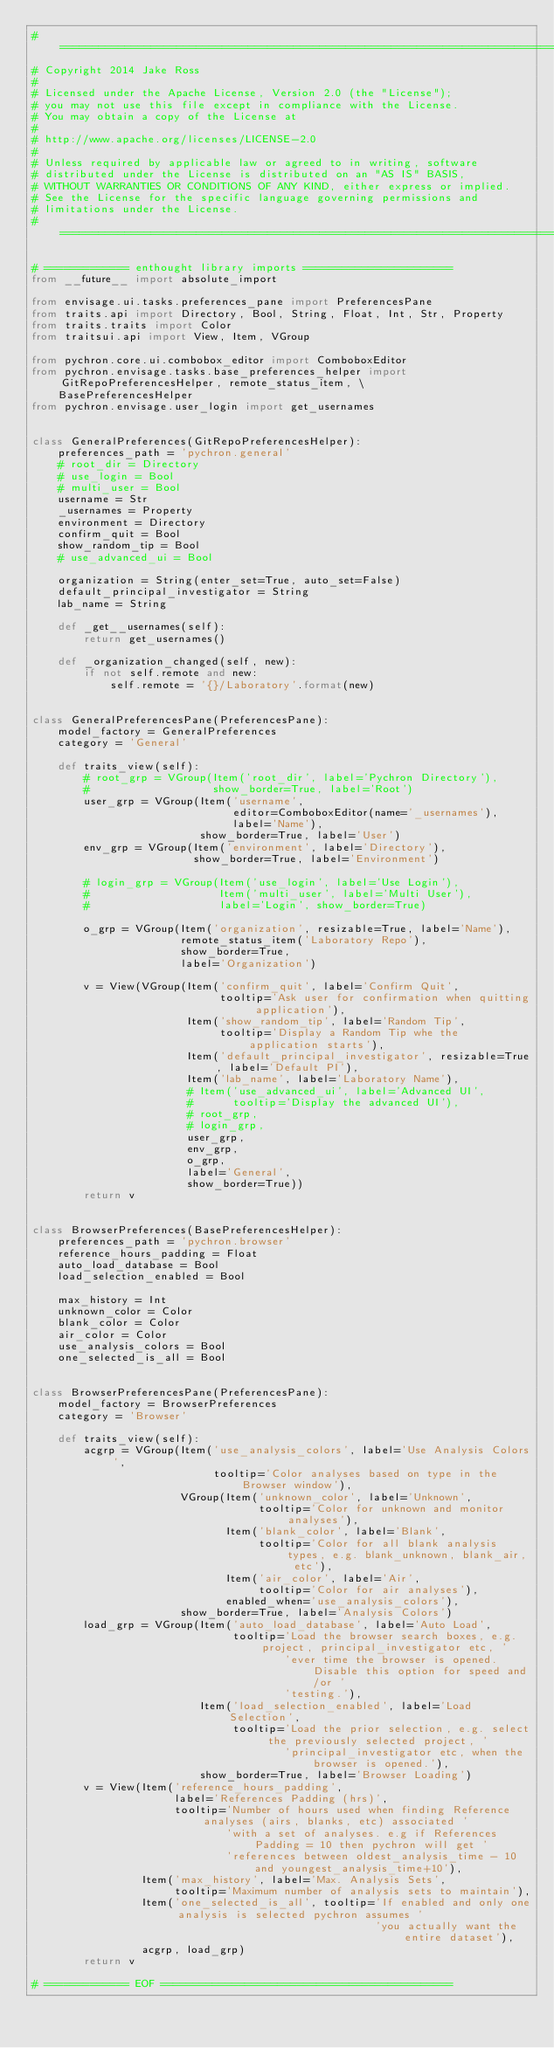<code> <loc_0><loc_0><loc_500><loc_500><_Python_># ===============================================================================
# Copyright 2014 Jake Ross
#
# Licensed under the Apache License, Version 2.0 (the "License");
# you may not use this file except in compliance with the License.
# You may obtain a copy of the License at
#
# http://www.apache.org/licenses/LICENSE-2.0
#
# Unless required by applicable law or agreed to in writing, software
# distributed under the License is distributed on an "AS IS" BASIS,
# WITHOUT WARRANTIES OR CONDITIONS OF ANY KIND, either express or implied.
# See the License for the specific language governing permissions and
# limitations under the License.
# ===============================================================================

# ============= enthought library imports =======================
from __future__ import absolute_import

from envisage.ui.tasks.preferences_pane import PreferencesPane
from traits.api import Directory, Bool, String, Float, Int, Str, Property
from traits.traits import Color
from traitsui.api import View, Item, VGroup

from pychron.core.ui.combobox_editor import ComboboxEditor
from pychron.envisage.tasks.base_preferences_helper import GitRepoPreferencesHelper, remote_status_item, \
    BasePreferencesHelper
from pychron.envisage.user_login import get_usernames


class GeneralPreferences(GitRepoPreferencesHelper):
    preferences_path = 'pychron.general'
    # root_dir = Directory
    # use_login = Bool
    # multi_user = Bool
    username = Str
    _usernames = Property
    environment = Directory
    confirm_quit = Bool
    show_random_tip = Bool
    # use_advanced_ui = Bool

    organization = String(enter_set=True, auto_set=False)
    default_principal_investigator = String
    lab_name = String

    def _get__usernames(self):
        return get_usernames()

    def _organization_changed(self, new):
        if not self.remote and new:
            self.remote = '{}/Laboratory'.format(new)


class GeneralPreferencesPane(PreferencesPane):
    model_factory = GeneralPreferences
    category = 'General'

    def traits_view(self):
        # root_grp = VGroup(Item('root_dir', label='Pychron Directory'),
        #                   show_border=True, label='Root')
        user_grp = VGroup(Item('username',
                               editor=ComboboxEditor(name='_usernames'),
                               label='Name'),
                          show_border=True, label='User')
        env_grp = VGroup(Item('environment', label='Directory'),
                         show_border=True, label='Environment')

        # login_grp = VGroup(Item('use_login', label='Use Login'),
        #                    Item('multi_user', label='Multi User'),
        #                    label='Login', show_border=True)

        o_grp = VGroup(Item('organization', resizable=True, label='Name'),
                       remote_status_item('Laboratory Repo'),
                       show_border=True,
                       label='Organization')

        v = View(VGroup(Item('confirm_quit', label='Confirm Quit',
                             tooltip='Ask user for confirmation when quitting application'),
                        Item('show_random_tip', label='Random Tip',
                             tooltip='Display a Random Tip whe the application starts'),
                        Item('default_principal_investigator', resizable=True, label='Default PI'),
                        Item('lab_name', label='Laboratory Name'),
                        # Item('use_advanced_ui', label='Advanced UI',
                        #      tooltip='Display the advanced UI'),
                        # root_grp,
                        # login_grp,
                        user_grp,
                        env_grp,
                        o_grp,
                        label='General',
                        show_border=True))
        return v


class BrowserPreferences(BasePreferencesHelper):
    preferences_path = 'pychron.browser'
    reference_hours_padding = Float
    auto_load_database = Bool
    load_selection_enabled = Bool

    max_history = Int
    unknown_color = Color
    blank_color = Color
    air_color = Color
    use_analysis_colors = Bool
    one_selected_is_all = Bool


class BrowserPreferencesPane(PreferencesPane):
    model_factory = BrowserPreferences
    category = 'Browser'

    def traits_view(self):
        acgrp = VGroup(Item('use_analysis_colors', label='Use Analysis Colors',
                            tooltip='Color analyses based on type in the Browser window'),
                       VGroup(Item('unknown_color', label='Unknown',
                                   tooltip='Color for unknown and monitor analyses'),
                              Item('blank_color', label='Blank',
                                   tooltip='Color for all blank analysis types, e.g. blank_unknown, blank_air, etc'),
                              Item('air_color', label='Air',
                                   tooltip='Color for air analyses'),
                              enabled_when='use_analysis_colors'),
                       show_border=True, label='Analysis Colors')
        load_grp = VGroup(Item('auto_load_database', label='Auto Load',
                               tooltip='Load the browser search boxes, e.g. project, principal_investigator etc, '
                                       'ever time the browser is opened. Disable this option for speed and/or '
                                       'testing.'),
                          Item('load_selection_enabled', label='Load Selection',
                               tooltip='Load the prior selection, e.g. select the previously selected project, '
                                       'principal_investigator etc, when the browser is opened.'),
                          show_border=True, label='Browser Loading')
        v = View(Item('reference_hours_padding',
                      label='References Padding (hrs)',
                      tooltip='Number of hours used when finding Reference analyses (airs, blanks, etc) associated '
                              'with a set of analyses. e.g if References Padding = 10 then pychron will get '
                              'references between oldest_analysis_time - 10 and youngest_analysis_time+10'),
                 Item('max_history', label='Max. Analysis Sets',
                      tooltip='Maximum number of analysis sets to maintain'),
                 Item('one_selected_is_all', tooltip='If enabled and only one analysis is selected pychron assumes '
                                                     'you actually want the entire dataset'),
                 acgrp, load_grp)
        return v

# ============= EOF =============================================
</code> 